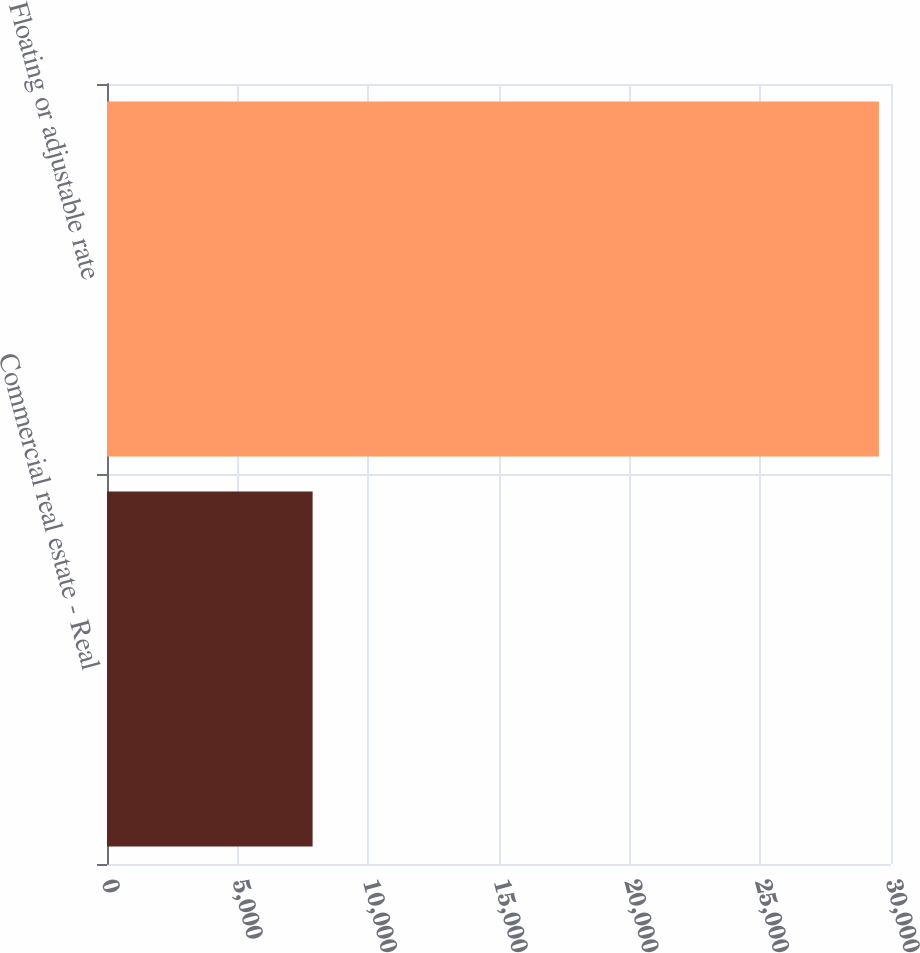Convert chart. <chart><loc_0><loc_0><loc_500><loc_500><bar_chart><fcel>Commercial real estate - Real<fcel>Floating or adjustable rate<nl><fcel>7868<fcel>29537<nl></chart> 